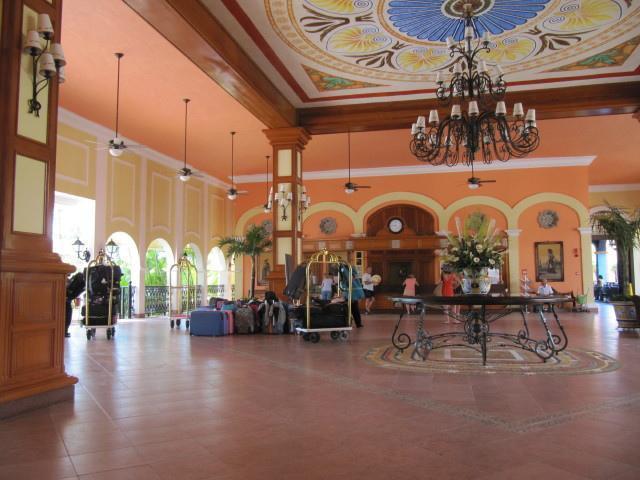What staff member is responsible for pushing the suitcase carts?
Select the accurate answer and provide justification: `Answer: choice
Rationale: srationale.`
Options: Bellhop, manager, janitor, maid. Answer: bellhop.
Rationale: A bunch of luggage is in a hotel lobby and a uniformed employee is pushing more on carts. hotels often have an employee to help get luggage to customer's rooms. 